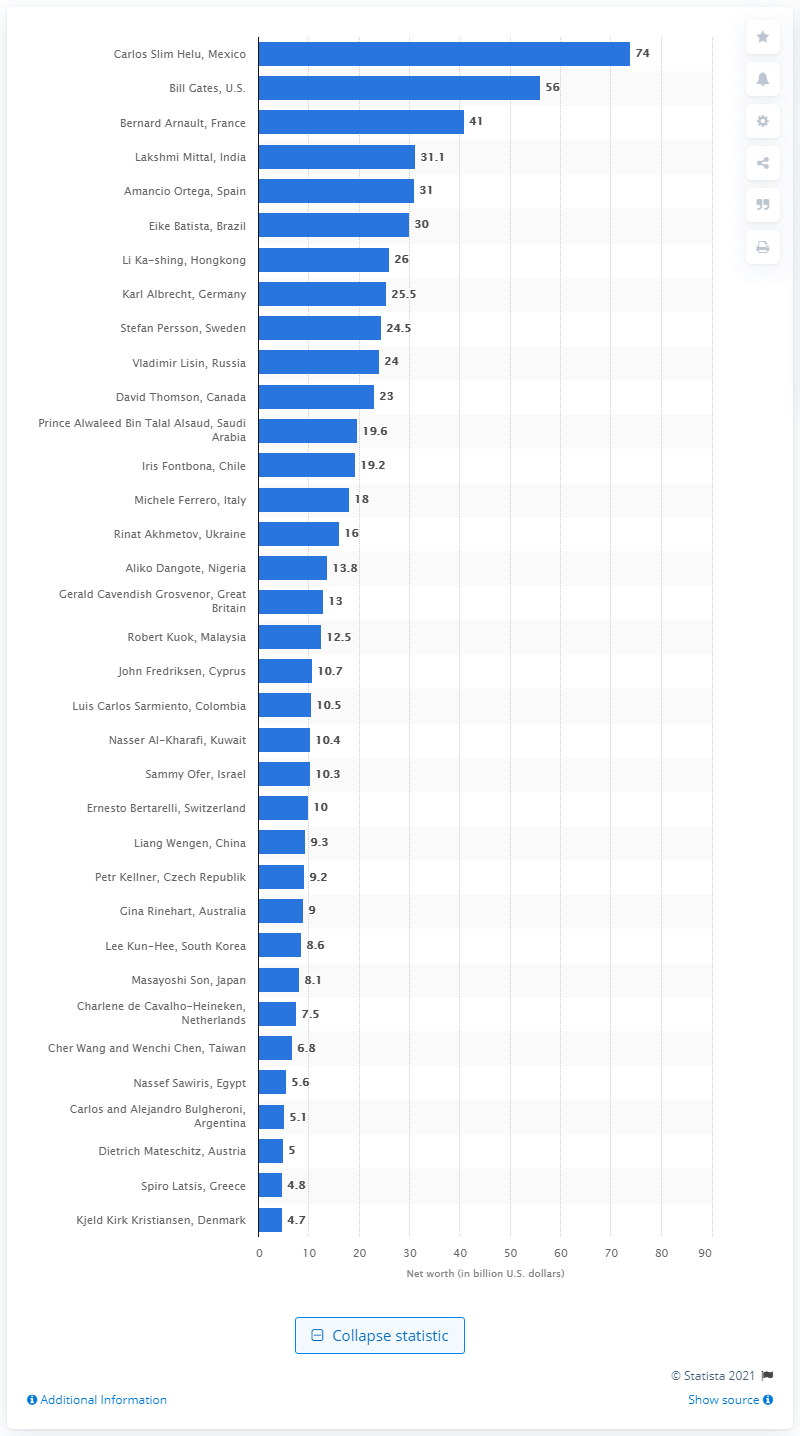Indicate a few pertinent items in this graphic. Carlos Slim Helú's wealth in 2011 was estimated to be approximately 74 billion U.S. dollars. 